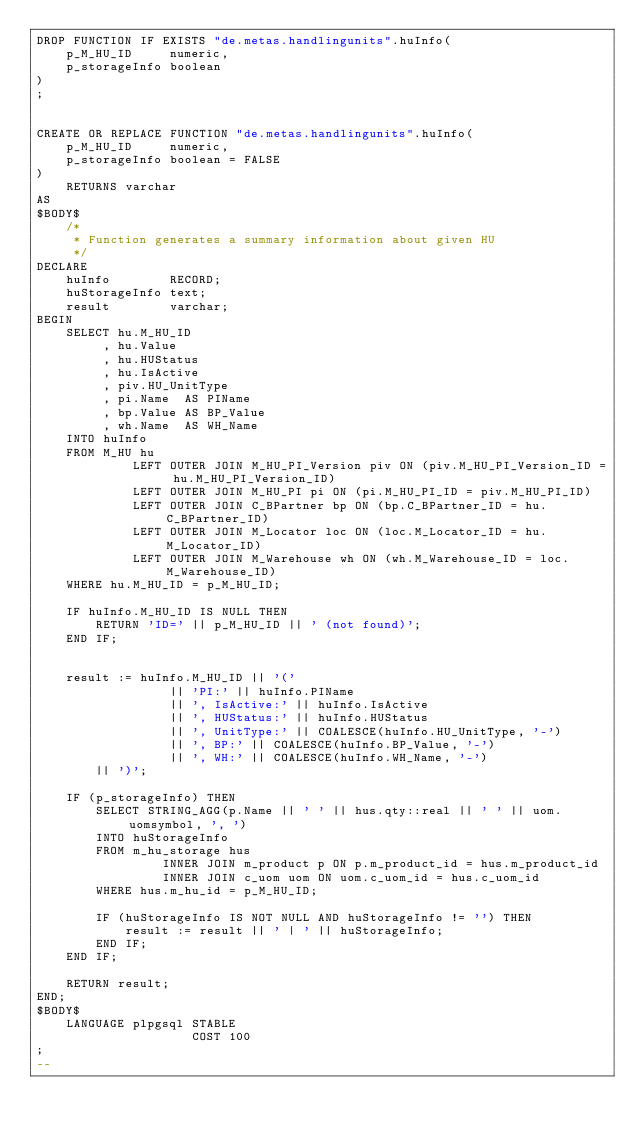Convert code to text. <code><loc_0><loc_0><loc_500><loc_500><_SQL_>DROP FUNCTION IF EXISTS "de.metas.handlingunits".huInfo(
    p_M_HU_ID     numeric,
    p_storageInfo boolean
)
;


CREATE OR REPLACE FUNCTION "de.metas.handlingunits".huInfo(
    p_M_HU_ID     numeric,
    p_storageInfo boolean = FALSE
)
    RETURNS varchar
AS
$BODY$
    /*
     * Function generates a summary information about given HU
     */
DECLARE
    huInfo        RECORD;
    huStorageInfo text;
    result        varchar;
BEGIN
    SELECT hu.M_HU_ID
         , hu.Value
         , hu.HUStatus
         , hu.IsActive
         , piv.HU_UnitType
         , pi.Name  AS PIName
         , bp.Value AS BP_Value
         , wh.Name  AS WH_Name
    INTO huInfo
    FROM M_HU hu
             LEFT OUTER JOIN M_HU_PI_Version piv ON (piv.M_HU_PI_Version_ID = hu.M_HU_PI_Version_ID)
             LEFT OUTER JOIN M_HU_PI pi ON (pi.M_HU_PI_ID = piv.M_HU_PI_ID)
             LEFT OUTER JOIN C_BPartner bp ON (bp.C_BPartner_ID = hu.C_BPartner_ID)
             LEFT OUTER JOIN M_Locator loc ON (loc.M_Locator_ID = hu.M_Locator_ID)
             LEFT OUTER JOIN M_Warehouse wh ON (wh.M_Warehouse_ID = loc.M_Warehouse_ID)
    WHERE hu.M_HU_ID = p_M_HU_ID;

    IF huInfo.M_HU_ID IS NULL THEN
        RETURN 'ID=' || p_M_HU_ID || ' (not found)';
    END IF;


    result := huInfo.M_HU_ID || '('
                  || 'PI:' || huInfo.PIName
                  || ', IsActive:' || huInfo.IsActive
                  || ', HUStatus:' || huInfo.HUStatus
                  || ', UnitType:' || COALESCE(huInfo.HU_UnitType, '-')
                  || ', BP:' || COALESCE(huInfo.BP_Value, '-')
                  || ', WH:' || COALESCE(huInfo.WH_Name, '-')
        || ')';

    IF (p_storageInfo) THEN
        SELECT STRING_AGG(p.Name || ' ' || hus.qty::real || ' ' || uom.uomsymbol, ', ')
        INTO huStorageInfo
        FROM m_hu_storage hus
                 INNER JOIN m_product p ON p.m_product_id = hus.m_product_id
                 INNER JOIN c_uom uom ON uom.c_uom_id = hus.c_uom_id
        WHERE hus.m_hu_id = p_M_HU_ID;

        IF (huStorageInfo IS NOT NULL AND huStorageInfo != '') THEN
            result := result || ' | ' || huStorageInfo;
        END IF;
    END IF;

    RETURN result;
END;
$BODY$
    LANGUAGE plpgsql STABLE
                     COST 100
;
--

</code> 